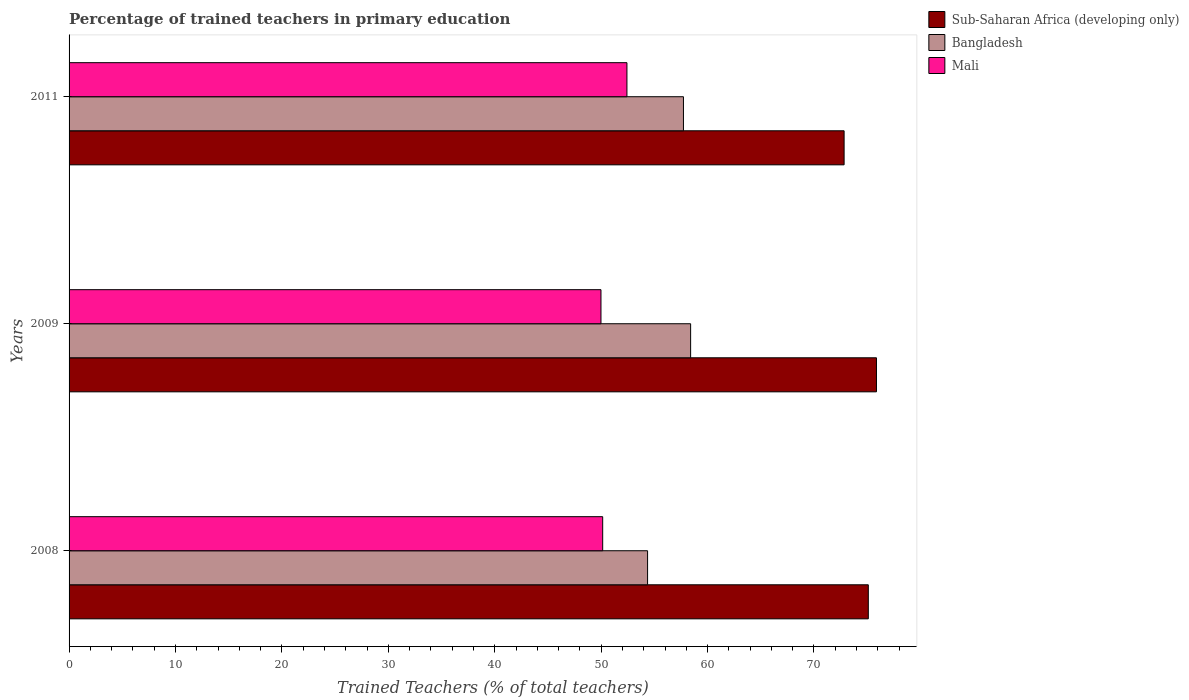Are the number of bars per tick equal to the number of legend labels?
Your answer should be very brief. Yes. How many bars are there on the 3rd tick from the top?
Offer a terse response. 3. What is the label of the 2nd group of bars from the top?
Your response must be concise. 2009. In how many cases, is the number of bars for a given year not equal to the number of legend labels?
Offer a terse response. 0. What is the percentage of trained teachers in Mali in 2011?
Offer a very short reply. 52.42. Across all years, what is the maximum percentage of trained teachers in Sub-Saharan Africa (developing only)?
Keep it short and to the point. 75.87. Across all years, what is the minimum percentage of trained teachers in Bangladesh?
Offer a terse response. 54.36. In which year was the percentage of trained teachers in Sub-Saharan Africa (developing only) maximum?
Your answer should be very brief. 2009. What is the total percentage of trained teachers in Bangladesh in the graph?
Your answer should be very brief. 170.51. What is the difference between the percentage of trained teachers in Sub-Saharan Africa (developing only) in 2009 and that in 2011?
Keep it short and to the point. 3.04. What is the difference between the percentage of trained teachers in Mali in 2011 and the percentage of trained teachers in Bangladesh in 2008?
Your answer should be compact. -1.94. What is the average percentage of trained teachers in Sub-Saharan Africa (developing only) per year?
Provide a short and direct response. 74.6. In the year 2008, what is the difference between the percentage of trained teachers in Bangladesh and percentage of trained teachers in Mali?
Give a very brief answer. 4.22. What is the ratio of the percentage of trained teachers in Bangladesh in 2008 to that in 2011?
Your response must be concise. 0.94. Is the percentage of trained teachers in Sub-Saharan Africa (developing only) in 2009 less than that in 2011?
Your answer should be compact. No. Is the difference between the percentage of trained teachers in Bangladesh in 2008 and 2009 greater than the difference between the percentage of trained teachers in Mali in 2008 and 2009?
Your answer should be compact. No. What is the difference between the highest and the second highest percentage of trained teachers in Mali?
Provide a short and direct response. 2.28. What is the difference between the highest and the lowest percentage of trained teachers in Mali?
Give a very brief answer. 2.44. In how many years, is the percentage of trained teachers in Mali greater than the average percentage of trained teachers in Mali taken over all years?
Your answer should be compact. 1. Is the sum of the percentage of trained teachers in Sub-Saharan Africa (developing only) in 2008 and 2009 greater than the maximum percentage of trained teachers in Mali across all years?
Provide a short and direct response. Yes. What does the 1st bar from the top in 2009 represents?
Offer a very short reply. Mali. Are all the bars in the graph horizontal?
Make the answer very short. Yes. What is the difference between two consecutive major ticks on the X-axis?
Make the answer very short. 10. Are the values on the major ticks of X-axis written in scientific E-notation?
Your response must be concise. No. How are the legend labels stacked?
Make the answer very short. Vertical. What is the title of the graph?
Keep it short and to the point. Percentage of trained teachers in primary education. Does "Heavily indebted poor countries" appear as one of the legend labels in the graph?
Keep it short and to the point. No. What is the label or title of the X-axis?
Ensure brevity in your answer.  Trained Teachers (% of total teachers). What is the Trained Teachers (% of total teachers) in Sub-Saharan Africa (developing only) in 2008?
Offer a very short reply. 75.11. What is the Trained Teachers (% of total teachers) of Bangladesh in 2008?
Your answer should be very brief. 54.36. What is the Trained Teachers (% of total teachers) in Mali in 2008?
Keep it short and to the point. 50.14. What is the Trained Teachers (% of total teachers) of Sub-Saharan Africa (developing only) in 2009?
Offer a very short reply. 75.87. What is the Trained Teachers (% of total teachers) in Bangladesh in 2009?
Make the answer very short. 58.41. What is the Trained Teachers (% of total teachers) of Mali in 2009?
Offer a very short reply. 49.98. What is the Trained Teachers (% of total teachers) in Sub-Saharan Africa (developing only) in 2011?
Your answer should be compact. 72.83. What is the Trained Teachers (% of total teachers) in Bangladesh in 2011?
Your answer should be very brief. 57.73. What is the Trained Teachers (% of total teachers) of Mali in 2011?
Offer a very short reply. 52.42. Across all years, what is the maximum Trained Teachers (% of total teachers) of Sub-Saharan Africa (developing only)?
Keep it short and to the point. 75.87. Across all years, what is the maximum Trained Teachers (% of total teachers) in Bangladesh?
Give a very brief answer. 58.41. Across all years, what is the maximum Trained Teachers (% of total teachers) of Mali?
Offer a terse response. 52.42. Across all years, what is the minimum Trained Teachers (% of total teachers) in Sub-Saharan Africa (developing only)?
Keep it short and to the point. 72.83. Across all years, what is the minimum Trained Teachers (% of total teachers) in Bangladesh?
Offer a very short reply. 54.36. Across all years, what is the minimum Trained Teachers (% of total teachers) of Mali?
Your answer should be compact. 49.98. What is the total Trained Teachers (% of total teachers) in Sub-Saharan Africa (developing only) in the graph?
Your answer should be very brief. 223.81. What is the total Trained Teachers (% of total teachers) in Bangladesh in the graph?
Your answer should be compact. 170.5. What is the total Trained Teachers (% of total teachers) in Mali in the graph?
Your response must be concise. 152.55. What is the difference between the Trained Teachers (% of total teachers) in Sub-Saharan Africa (developing only) in 2008 and that in 2009?
Offer a very short reply. -0.77. What is the difference between the Trained Teachers (% of total teachers) in Bangladesh in 2008 and that in 2009?
Make the answer very short. -4.04. What is the difference between the Trained Teachers (% of total teachers) of Mali in 2008 and that in 2009?
Your answer should be compact. 0.16. What is the difference between the Trained Teachers (% of total teachers) of Sub-Saharan Africa (developing only) in 2008 and that in 2011?
Your response must be concise. 2.27. What is the difference between the Trained Teachers (% of total teachers) of Bangladesh in 2008 and that in 2011?
Your answer should be very brief. -3.37. What is the difference between the Trained Teachers (% of total teachers) in Mali in 2008 and that in 2011?
Offer a very short reply. -2.28. What is the difference between the Trained Teachers (% of total teachers) of Sub-Saharan Africa (developing only) in 2009 and that in 2011?
Your response must be concise. 3.04. What is the difference between the Trained Teachers (% of total teachers) in Bangladesh in 2009 and that in 2011?
Ensure brevity in your answer.  0.67. What is the difference between the Trained Teachers (% of total teachers) in Mali in 2009 and that in 2011?
Ensure brevity in your answer.  -2.44. What is the difference between the Trained Teachers (% of total teachers) in Sub-Saharan Africa (developing only) in 2008 and the Trained Teachers (% of total teachers) in Bangladesh in 2009?
Offer a very short reply. 16.7. What is the difference between the Trained Teachers (% of total teachers) of Sub-Saharan Africa (developing only) in 2008 and the Trained Teachers (% of total teachers) of Mali in 2009?
Your answer should be very brief. 25.12. What is the difference between the Trained Teachers (% of total teachers) of Bangladesh in 2008 and the Trained Teachers (% of total teachers) of Mali in 2009?
Provide a short and direct response. 4.38. What is the difference between the Trained Teachers (% of total teachers) in Sub-Saharan Africa (developing only) in 2008 and the Trained Teachers (% of total teachers) in Bangladesh in 2011?
Make the answer very short. 17.37. What is the difference between the Trained Teachers (% of total teachers) in Sub-Saharan Africa (developing only) in 2008 and the Trained Teachers (% of total teachers) in Mali in 2011?
Your answer should be compact. 22.68. What is the difference between the Trained Teachers (% of total teachers) of Bangladesh in 2008 and the Trained Teachers (% of total teachers) of Mali in 2011?
Your answer should be very brief. 1.94. What is the difference between the Trained Teachers (% of total teachers) of Sub-Saharan Africa (developing only) in 2009 and the Trained Teachers (% of total teachers) of Bangladesh in 2011?
Offer a terse response. 18.14. What is the difference between the Trained Teachers (% of total teachers) in Sub-Saharan Africa (developing only) in 2009 and the Trained Teachers (% of total teachers) in Mali in 2011?
Your answer should be compact. 23.45. What is the difference between the Trained Teachers (% of total teachers) of Bangladesh in 2009 and the Trained Teachers (% of total teachers) of Mali in 2011?
Make the answer very short. 5.98. What is the average Trained Teachers (% of total teachers) of Sub-Saharan Africa (developing only) per year?
Provide a succinct answer. 74.6. What is the average Trained Teachers (% of total teachers) of Bangladesh per year?
Your response must be concise. 56.84. What is the average Trained Teachers (% of total teachers) of Mali per year?
Your answer should be very brief. 50.85. In the year 2008, what is the difference between the Trained Teachers (% of total teachers) of Sub-Saharan Africa (developing only) and Trained Teachers (% of total teachers) of Bangladesh?
Your response must be concise. 20.74. In the year 2008, what is the difference between the Trained Teachers (% of total teachers) of Sub-Saharan Africa (developing only) and Trained Teachers (% of total teachers) of Mali?
Offer a terse response. 24.96. In the year 2008, what is the difference between the Trained Teachers (% of total teachers) in Bangladesh and Trained Teachers (% of total teachers) in Mali?
Your answer should be compact. 4.22. In the year 2009, what is the difference between the Trained Teachers (% of total teachers) in Sub-Saharan Africa (developing only) and Trained Teachers (% of total teachers) in Bangladesh?
Keep it short and to the point. 17.46. In the year 2009, what is the difference between the Trained Teachers (% of total teachers) in Sub-Saharan Africa (developing only) and Trained Teachers (% of total teachers) in Mali?
Provide a succinct answer. 25.89. In the year 2009, what is the difference between the Trained Teachers (% of total teachers) of Bangladesh and Trained Teachers (% of total teachers) of Mali?
Provide a short and direct response. 8.42. In the year 2011, what is the difference between the Trained Teachers (% of total teachers) in Sub-Saharan Africa (developing only) and Trained Teachers (% of total teachers) in Bangladesh?
Offer a very short reply. 15.1. In the year 2011, what is the difference between the Trained Teachers (% of total teachers) of Sub-Saharan Africa (developing only) and Trained Teachers (% of total teachers) of Mali?
Your response must be concise. 20.41. In the year 2011, what is the difference between the Trained Teachers (% of total teachers) of Bangladesh and Trained Teachers (% of total teachers) of Mali?
Provide a short and direct response. 5.31. What is the ratio of the Trained Teachers (% of total teachers) in Bangladesh in 2008 to that in 2009?
Your answer should be compact. 0.93. What is the ratio of the Trained Teachers (% of total teachers) of Sub-Saharan Africa (developing only) in 2008 to that in 2011?
Ensure brevity in your answer.  1.03. What is the ratio of the Trained Teachers (% of total teachers) of Bangladesh in 2008 to that in 2011?
Your answer should be compact. 0.94. What is the ratio of the Trained Teachers (% of total teachers) of Mali in 2008 to that in 2011?
Keep it short and to the point. 0.96. What is the ratio of the Trained Teachers (% of total teachers) in Sub-Saharan Africa (developing only) in 2009 to that in 2011?
Offer a very short reply. 1.04. What is the ratio of the Trained Teachers (% of total teachers) of Bangladesh in 2009 to that in 2011?
Make the answer very short. 1.01. What is the ratio of the Trained Teachers (% of total teachers) of Mali in 2009 to that in 2011?
Offer a terse response. 0.95. What is the difference between the highest and the second highest Trained Teachers (% of total teachers) of Sub-Saharan Africa (developing only)?
Provide a succinct answer. 0.77. What is the difference between the highest and the second highest Trained Teachers (% of total teachers) in Bangladesh?
Provide a short and direct response. 0.67. What is the difference between the highest and the second highest Trained Teachers (% of total teachers) of Mali?
Keep it short and to the point. 2.28. What is the difference between the highest and the lowest Trained Teachers (% of total teachers) of Sub-Saharan Africa (developing only)?
Provide a succinct answer. 3.04. What is the difference between the highest and the lowest Trained Teachers (% of total teachers) in Bangladesh?
Your answer should be compact. 4.04. What is the difference between the highest and the lowest Trained Teachers (% of total teachers) of Mali?
Ensure brevity in your answer.  2.44. 